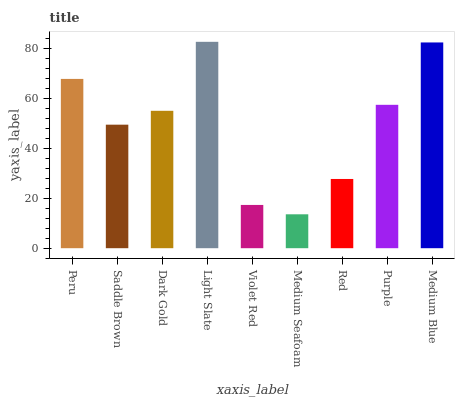Is Saddle Brown the minimum?
Answer yes or no. No. Is Saddle Brown the maximum?
Answer yes or no. No. Is Peru greater than Saddle Brown?
Answer yes or no. Yes. Is Saddle Brown less than Peru?
Answer yes or no. Yes. Is Saddle Brown greater than Peru?
Answer yes or no. No. Is Peru less than Saddle Brown?
Answer yes or no. No. Is Dark Gold the high median?
Answer yes or no. Yes. Is Dark Gold the low median?
Answer yes or no. Yes. Is Purple the high median?
Answer yes or no. No. Is Medium Blue the low median?
Answer yes or no. No. 